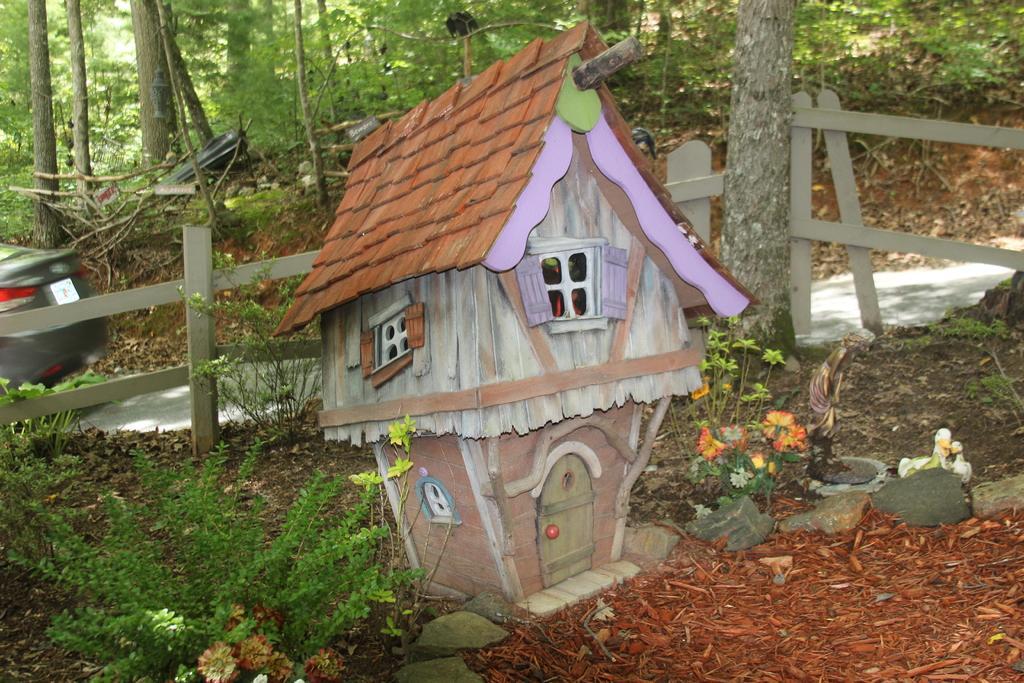How would you summarize this image in a sentence or two? In the foreground of this image, there is a structure of a hut, few plants, stones, sculptures are on the ground. In the background, there is a railing, a tree, a plant, car on the road, trees and a bird on the pole like structure. 